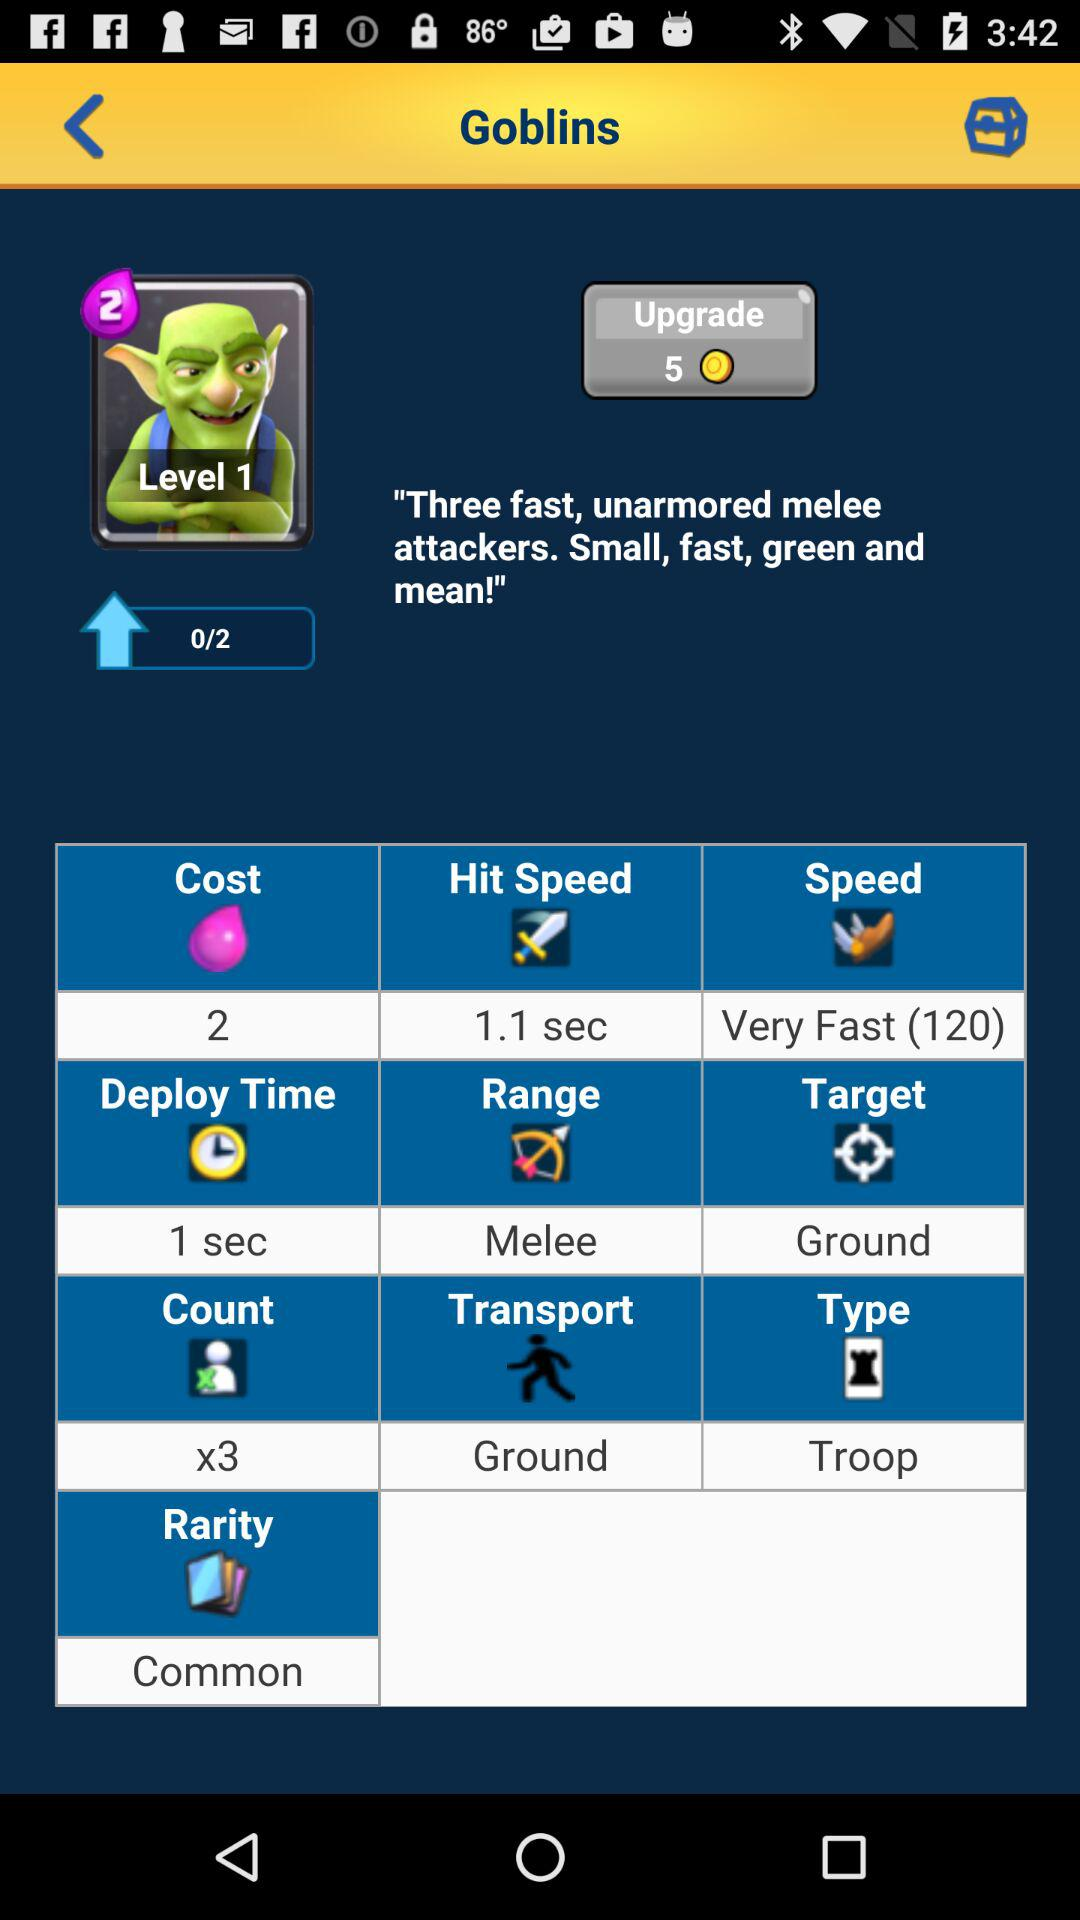What is the time in seconds for "Hit Speed"? The time for "Hit Speed" is 1.1 seconds. 